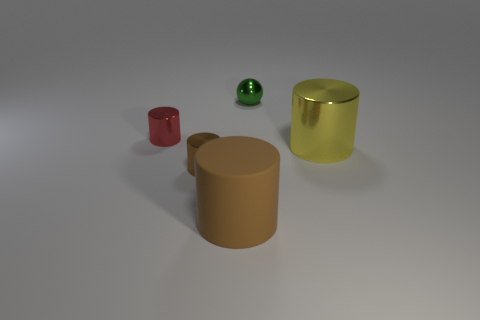Is the number of small green shiny things in front of the big yellow shiny cylinder greater than the number of tiny objects that are behind the tiny brown metallic cylinder?
Your answer should be compact. No. There is a thing that is behind the tiny thing left of the shiny thing in front of the yellow metal cylinder; how big is it?
Give a very brief answer. Small. Are there any cylinders of the same color as the tiny shiny ball?
Keep it short and to the point. No. How many tiny things are there?
Offer a terse response. 3. The small object in front of the large cylinder behind the brown thing that is behind the big brown rubber cylinder is made of what material?
Provide a short and direct response. Metal. Are there any green cylinders that have the same material as the red thing?
Your answer should be very brief. No. Is the material of the yellow cylinder the same as the small ball?
Provide a short and direct response. Yes. What number of blocks are tiny brown shiny objects or green things?
Your answer should be very brief. 0. There is a tiny ball that is made of the same material as the small brown thing; what is its color?
Your answer should be very brief. Green. Are there fewer small green matte balls than tiny green shiny things?
Give a very brief answer. Yes. 